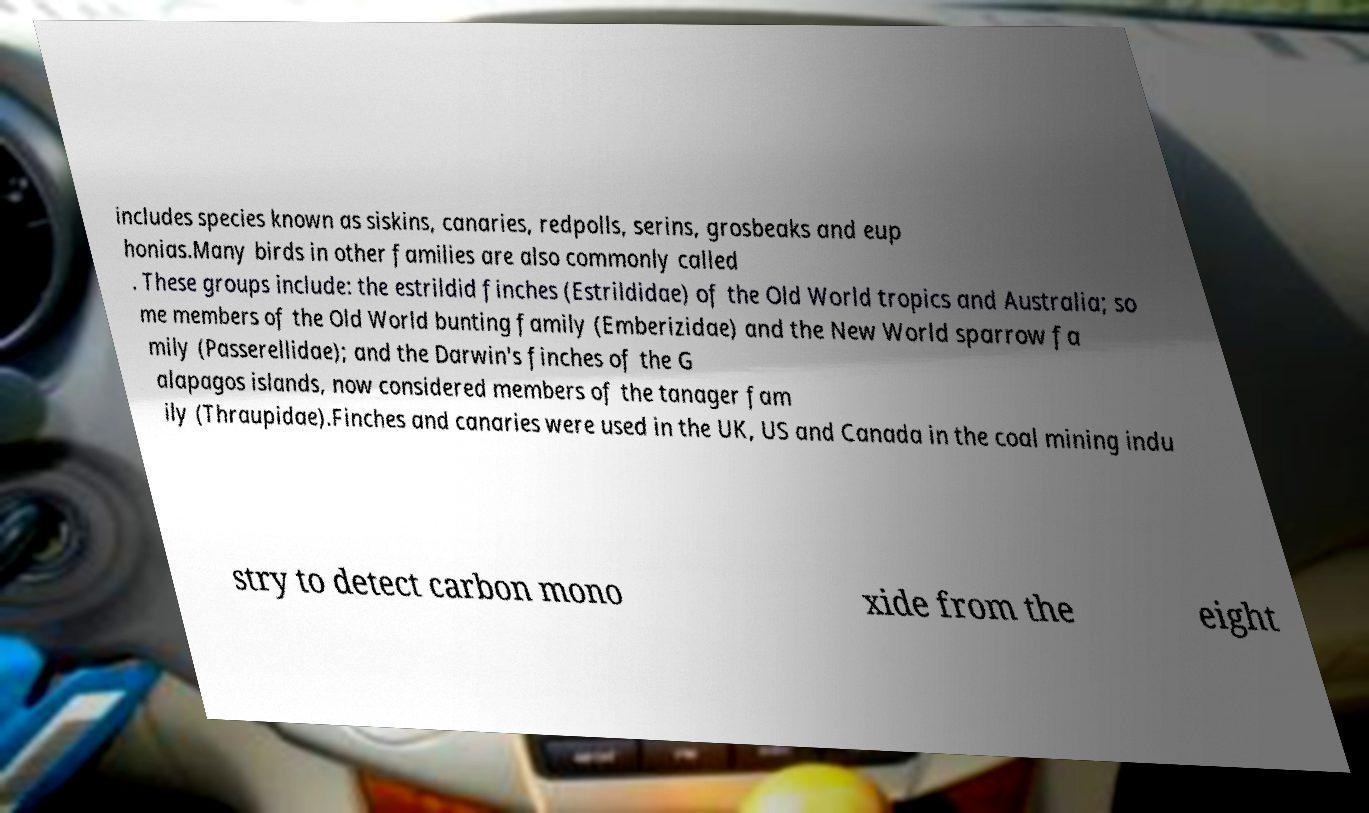Please identify and transcribe the text found in this image. includes species known as siskins, canaries, redpolls, serins, grosbeaks and eup honias.Many birds in other families are also commonly called . These groups include: the estrildid finches (Estrildidae) of the Old World tropics and Australia; so me members of the Old World bunting family (Emberizidae) and the New World sparrow fa mily (Passerellidae); and the Darwin's finches of the G alapagos islands, now considered members of the tanager fam ily (Thraupidae).Finches and canaries were used in the UK, US and Canada in the coal mining indu stry to detect carbon mono xide from the eight 